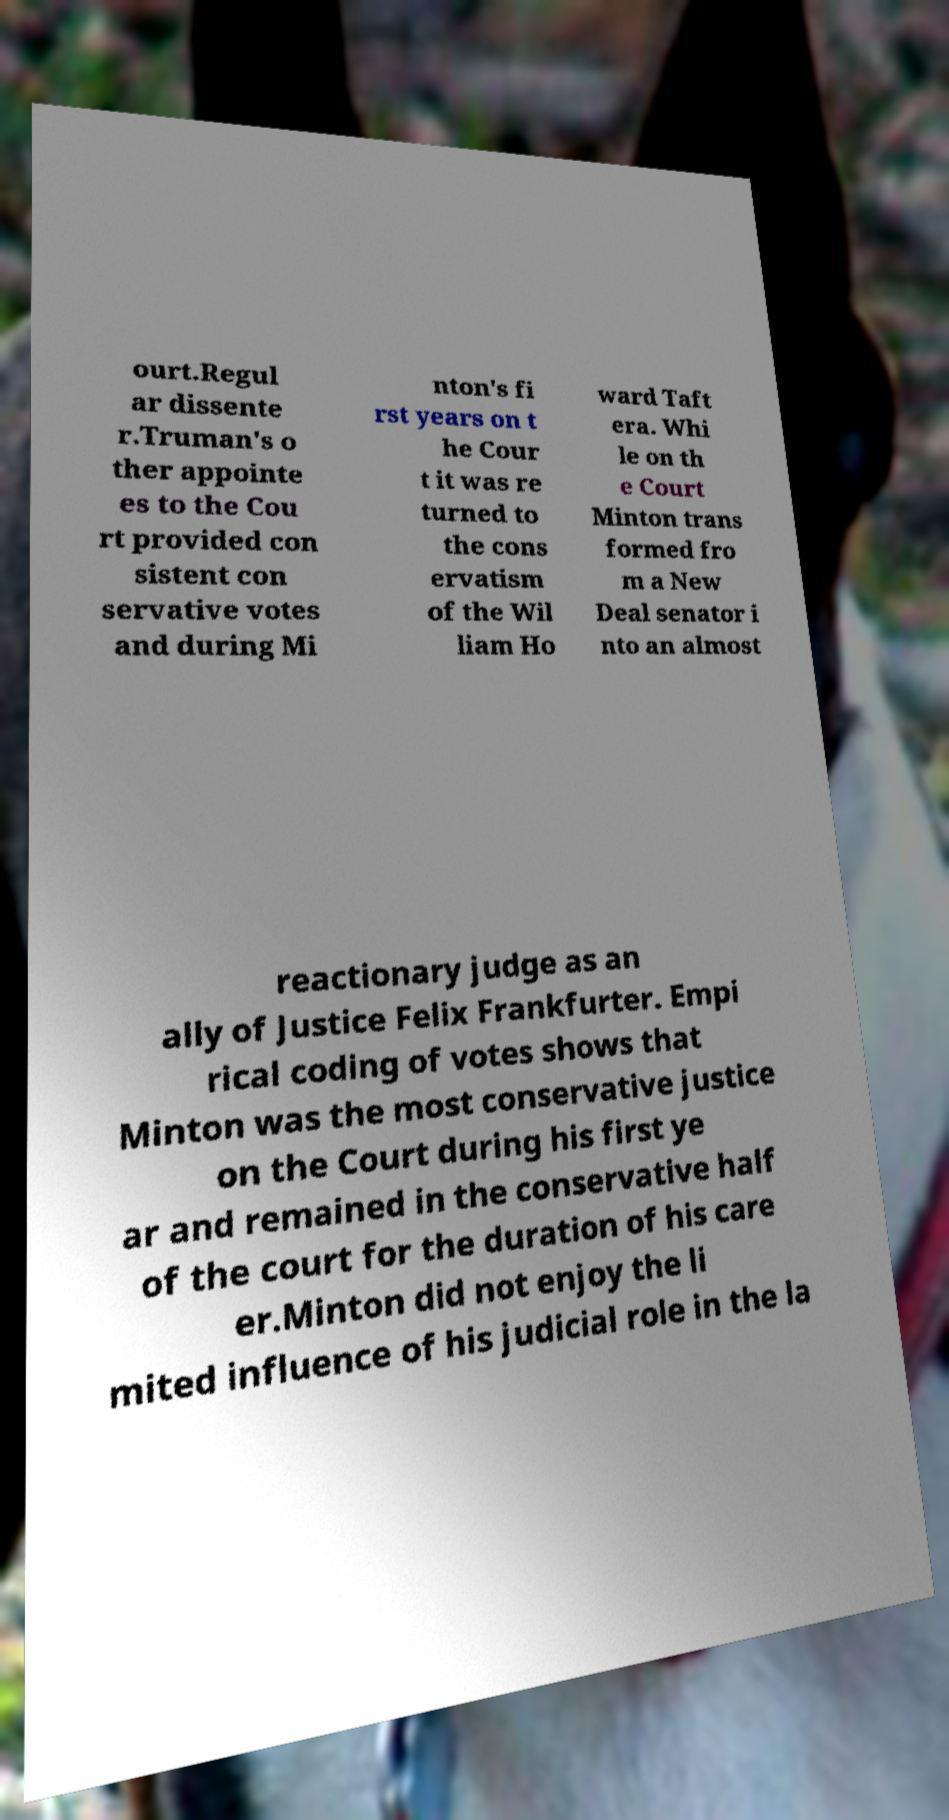Can you read and provide the text displayed in the image?This photo seems to have some interesting text. Can you extract and type it out for me? ourt.Regul ar dissente r.Truman's o ther appointe es to the Cou rt provided con sistent con servative votes and during Mi nton's fi rst years on t he Cour t it was re turned to the cons ervatism of the Wil liam Ho ward Taft era. Whi le on th e Court Minton trans formed fro m a New Deal senator i nto an almost reactionary judge as an ally of Justice Felix Frankfurter. Empi rical coding of votes shows that Minton was the most conservative justice on the Court during his first ye ar and remained in the conservative half of the court for the duration of his care er.Minton did not enjoy the li mited influence of his judicial role in the la 